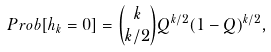<formula> <loc_0><loc_0><loc_500><loc_500>P r o b [ h _ { k } = 0 ] = \binom { k } { k / 2 } Q ^ { k / 2 } ( 1 - Q ) ^ { k / 2 } ,</formula> 